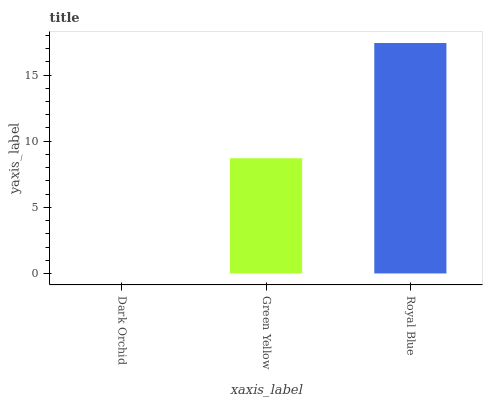Is Green Yellow the minimum?
Answer yes or no. No. Is Green Yellow the maximum?
Answer yes or no. No. Is Green Yellow greater than Dark Orchid?
Answer yes or no. Yes. Is Dark Orchid less than Green Yellow?
Answer yes or no. Yes. Is Dark Orchid greater than Green Yellow?
Answer yes or no. No. Is Green Yellow less than Dark Orchid?
Answer yes or no. No. Is Green Yellow the high median?
Answer yes or no. Yes. Is Green Yellow the low median?
Answer yes or no. Yes. Is Dark Orchid the high median?
Answer yes or no. No. Is Dark Orchid the low median?
Answer yes or no. No. 